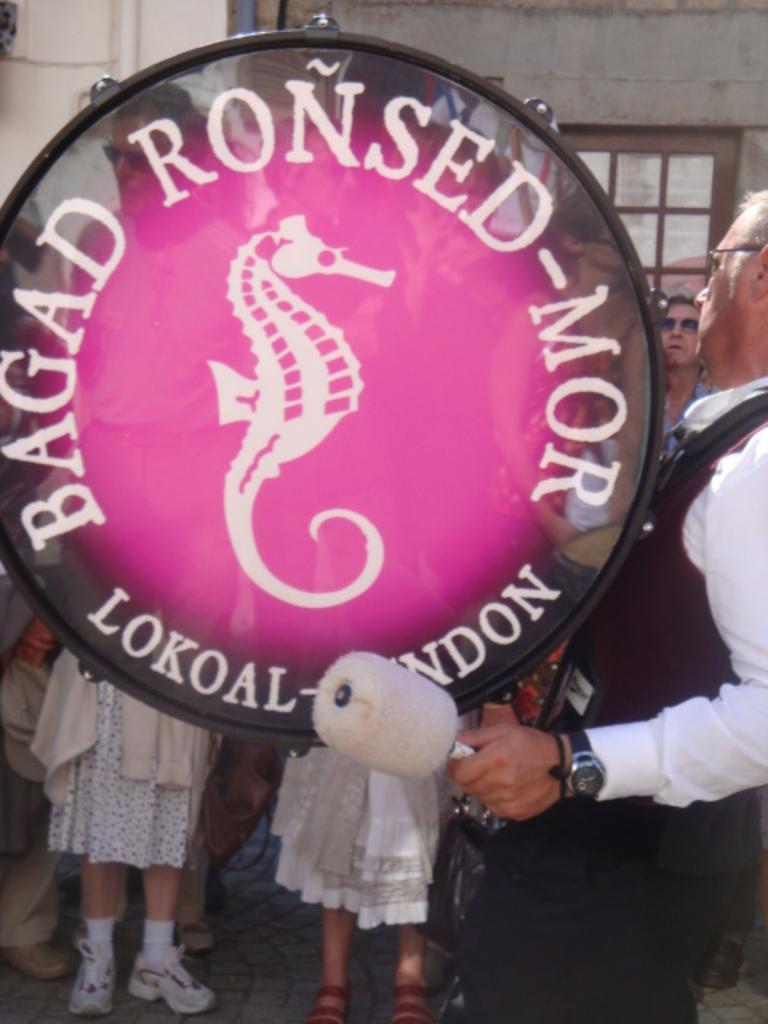Can you describe this image briefly? In this picture there is a man who is wearing spectacle, shirt, watch, band and trouser. He is holding stick and playing the drum. In the background there are two women who are wearing white dress and footwear. In the top right we can see the building. In the right there is a man who is wearing goggle and shirt. He is standing near to the door. At the top left corner we can see the pipes on the wall. 